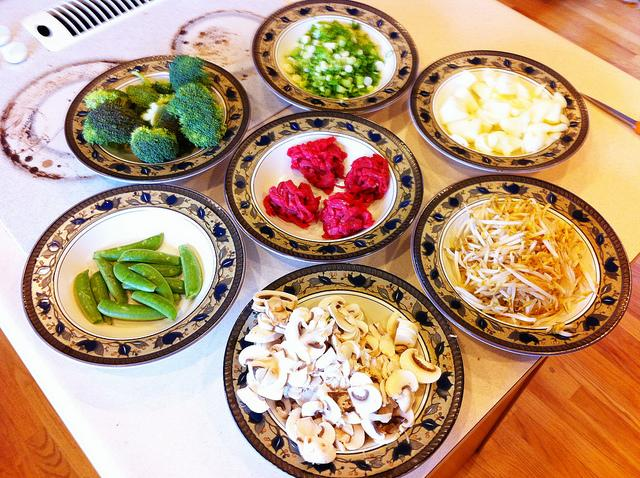How many plates are on the table?

Choices:
A) one
B) two
C) seven
D) four seven 